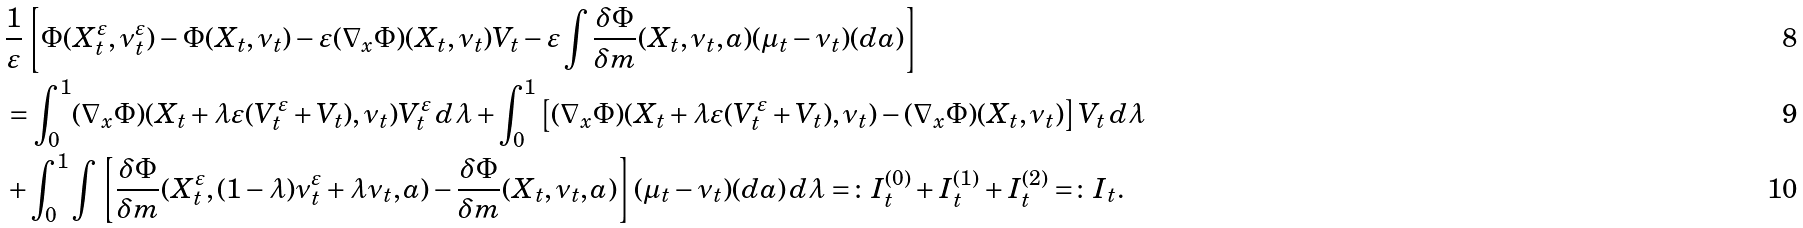<formula> <loc_0><loc_0><loc_500><loc_500>& \frac { 1 } { \varepsilon } \left [ \Phi ( X ^ { \varepsilon } _ { t } , \nu ^ { \varepsilon } _ { t } ) - \Phi ( X _ { t } , \nu _ { t } ) - \varepsilon ( \nabla _ { x } \Phi ) ( X _ { t } , \nu _ { t } ) V _ { t } - \varepsilon \int \frac { \delta \Phi } { \delta m } ( X _ { t } , \nu _ { t } , a ) ( \mu _ { t } - \nu _ { t } ) ( d a ) \right ] \\ & = \int _ { 0 } ^ { 1 } ( \nabla _ { x } \Phi ) ( X _ { t } + \lambda \varepsilon ( V ^ { \varepsilon } _ { t } + V _ { t } ) , \nu _ { t } ) V ^ { \varepsilon } _ { t } \, d \lambda + \int _ { 0 } ^ { 1 } \left [ ( \nabla _ { x } \Phi ) ( X _ { t } + \lambda \varepsilon ( V ^ { \varepsilon } _ { t } + V _ { t } ) , \nu _ { t } ) - ( \nabla _ { x } \Phi ) ( X _ { t } , \nu _ { t } ) \right ] V _ { t } \, d \lambda \\ & + \int _ { 0 } ^ { 1 } \int \left [ \frac { \delta \Phi } { \delta m } ( X ^ { \varepsilon } _ { t } , ( 1 - \lambda ) \nu ^ { \varepsilon } _ { t } + \lambda \nu _ { t } , a ) - \frac { \delta \Phi } { \delta m } ( X _ { t } , \nu _ { t } , a ) \right ] ( \mu _ { t } - \nu _ { t } ) ( d a ) \, d \lambda = \colon I ^ { ( 0 ) } _ { t } + I ^ { ( 1 ) } _ { t } + I ^ { ( 2 ) } _ { t } = \colon I _ { t } .</formula> 